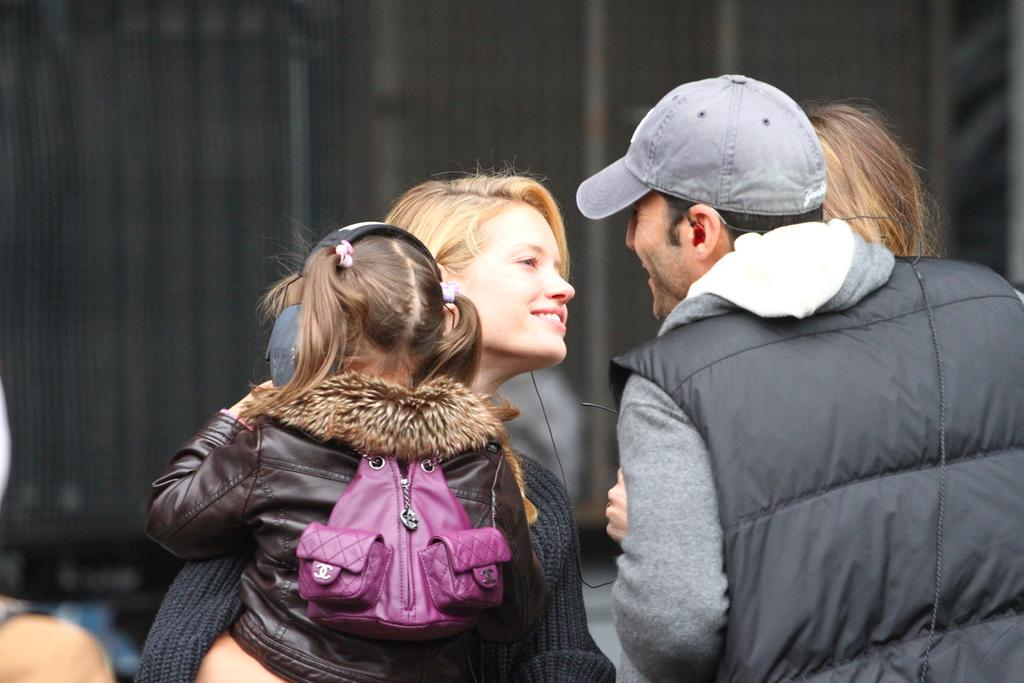What is happening in the image? There are people standing in the image, including a woman who is carrying a child. Can you describe the relationship between the woman and the child? The woman is carrying the child, which suggests that they might be related or that the woman is assisting the child. What type of stitch is being used by the grandmother in the image? There is no grandmother or stitching activity present in the image. What scene is being depicted in the image? The image does not depict a specific scene; it simply shows people standing, including a woman carrying a child. 